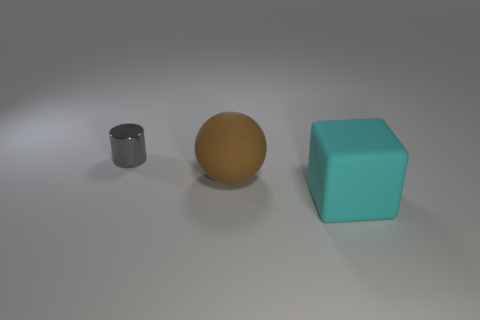Add 2 brown metal balls. How many objects exist? 5 Subtract all cubes. How many objects are left? 2 Add 2 tiny gray shiny things. How many tiny gray shiny things are left? 3 Add 3 small gray metal things. How many small gray metal things exist? 4 Subtract 1 brown spheres. How many objects are left? 2 Subtract all large rubber objects. Subtract all tiny matte cylinders. How many objects are left? 1 